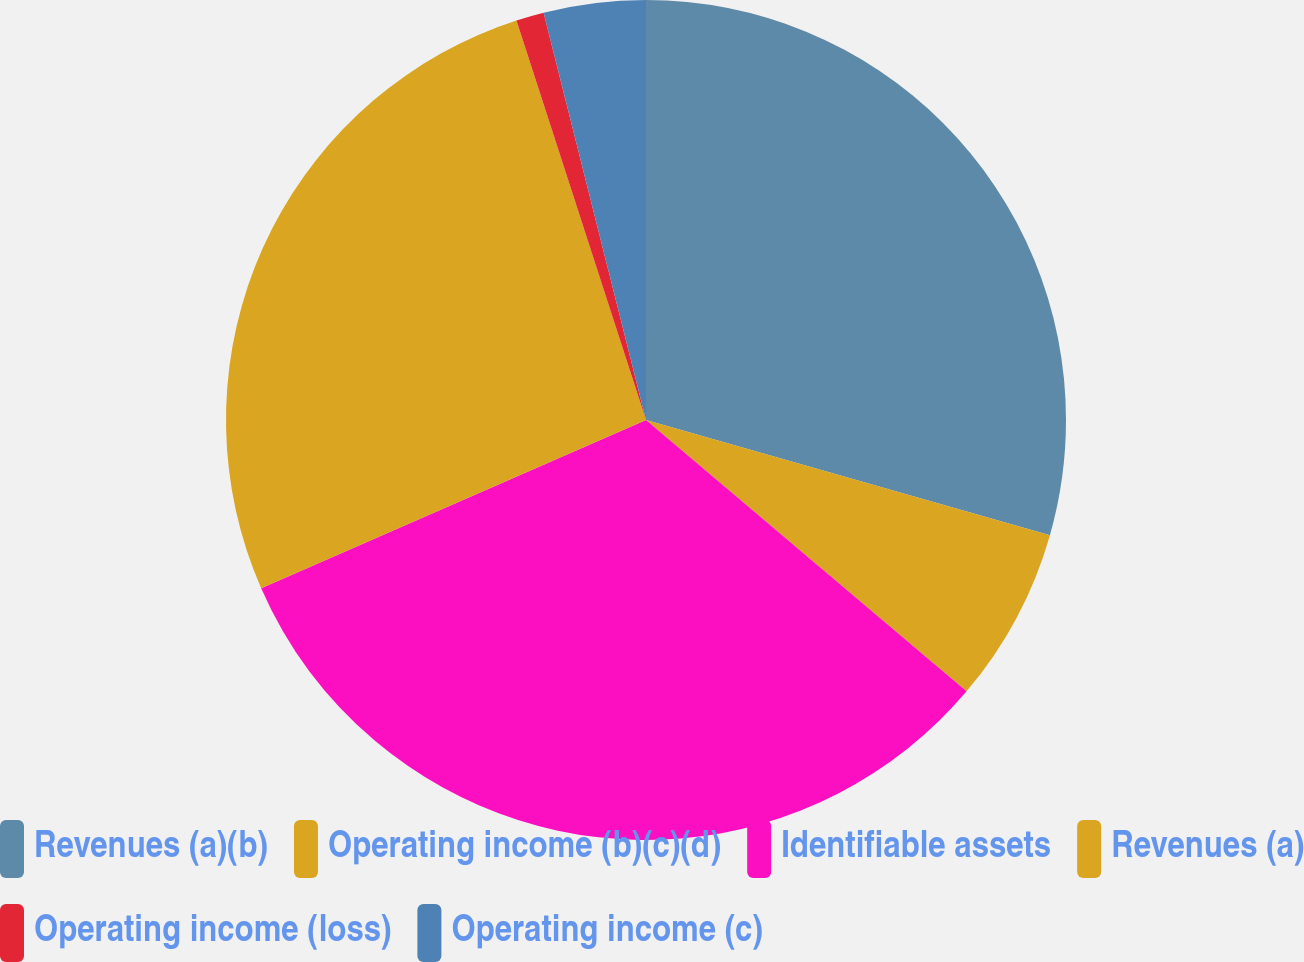Convert chart. <chart><loc_0><loc_0><loc_500><loc_500><pie_chart><fcel>Revenues (a)(b)<fcel>Operating income (b)(c)(d)<fcel>Identifiable assets<fcel>Revenues (a)<fcel>Operating income (loss)<fcel>Operating income (c)<nl><fcel>29.42%<fcel>6.76%<fcel>32.26%<fcel>26.57%<fcel>1.07%<fcel>3.92%<nl></chart> 